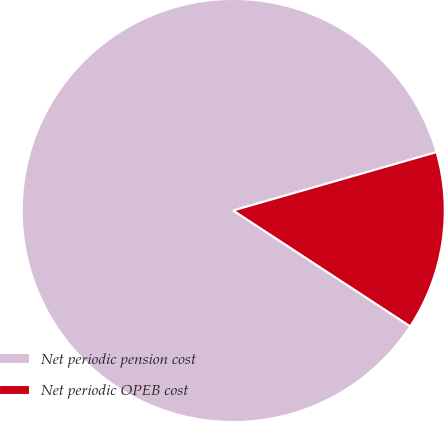Convert chart to OTSL. <chart><loc_0><loc_0><loc_500><loc_500><pie_chart><fcel>Net periodic pension cost<fcel>Net periodic OPEB cost<nl><fcel>86.33%<fcel>13.67%<nl></chart> 